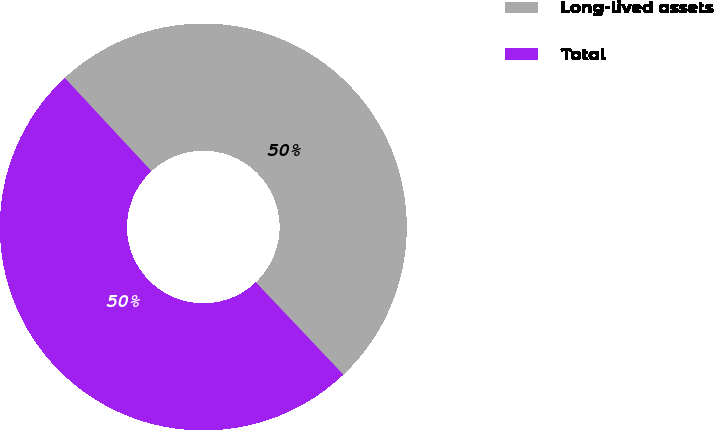<chart> <loc_0><loc_0><loc_500><loc_500><pie_chart><fcel>Long-lived assets<fcel>Total<nl><fcel>49.85%<fcel>50.15%<nl></chart> 